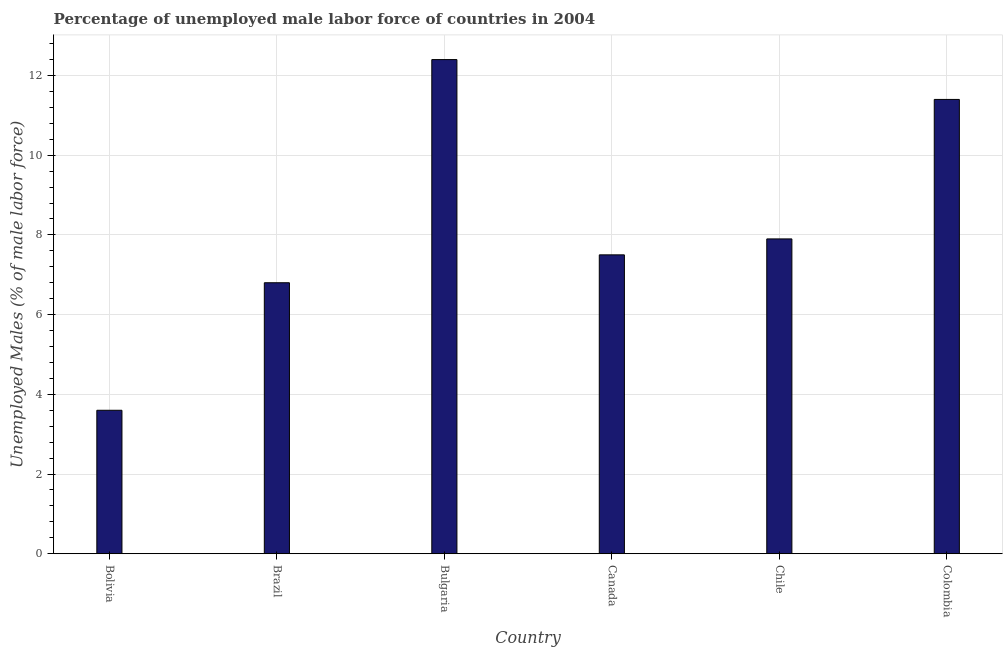Does the graph contain any zero values?
Make the answer very short. No. Does the graph contain grids?
Make the answer very short. Yes. What is the title of the graph?
Keep it short and to the point. Percentage of unemployed male labor force of countries in 2004. What is the label or title of the Y-axis?
Offer a terse response. Unemployed Males (% of male labor force). What is the total unemployed male labour force in Bulgaria?
Your answer should be compact. 12.4. Across all countries, what is the maximum total unemployed male labour force?
Provide a short and direct response. 12.4. Across all countries, what is the minimum total unemployed male labour force?
Offer a terse response. 3.6. What is the sum of the total unemployed male labour force?
Provide a short and direct response. 49.6. What is the average total unemployed male labour force per country?
Your answer should be very brief. 8.27. What is the median total unemployed male labour force?
Your answer should be very brief. 7.7. In how many countries, is the total unemployed male labour force greater than 11.6 %?
Offer a terse response. 1. What is the ratio of the total unemployed male labour force in Brazil to that in Chile?
Provide a succinct answer. 0.86. What is the difference between the highest and the second highest total unemployed male labour force?
Provide a succinct answer. 1. Is the sum of the total unemployed male labour force in Bolivia and Brazil greater than the maximum total unemployed male labour force across all countries?
Provide a succinct answer. No. Are all the bars in the graph horizontal?
Provide a succinct answer. No. How many countries are there in the graph?
Offer a terse response. 6. Are the values on the major ticks of Y-axis written in scientific E-notation?
Offer a very short reply. No. What is the Unemployed Males (% of male labor force) in Bolivia?
Provide a succinct answer. 3.6. What is the Unemployed Males (% of male labor force) of Brazil?
Your response must be concise. 6.8. What is the Unemployed Males (% of male labor force) in Bulgaria?
Your response must be concise. 12.4. What is the Unemployed Males (% of male labor force) of Canada?
Give a very brief answer. 7.5. What is the Unemployed Males (% of male labor force) of Chile?
Offer a terse response. 7.9. What is the Unemployed Males (% of male labor force) in Colombia?
Offer a terse response. 11.4. What is the difference between the Unemployed Males (% of male labor force) in Bolivia and Brazil?
Ensure brevity in your answer.  -3.2. What is the difference between the Unemployed Males (% of male labor force) in Bolivia and Bulgaria?
Your answer should be very brief. -8.8. What is the difference between the Unemployed Males (% of male labor force) in Bolivia and Chile?
Your answer should be very brief. -4.3. What is the difference between the Unemployed Males (% of male labor force) in Bolivia and Colombia?
Ensure brevity in your answer.  -7.8. What is the difference between the Unemployed Males (% of male labor force) in Brazil and Bulgaria?
Ensure brevity in your answer.  -5.6. What is the difference between the Unemployed Males (% of male labor force) in Brazil and Colombia?
Provide a short and direct response. -4.6. What is the difference between the Unemployed Males (% of male labor force) in Bulgaria and Colombia?
Make the answer very short. 1. What is the difference between the Unemployed Males (% of male labor force) in Canada and Chile?
Offer a terse response. -0.4. What is the ratio of the Unemployed Males (% of male labor force) in Bolivia to that in Brazil?
Make the answer very short. 0.53. What is the ratio of the Unemployed Males (% of male labor force) in Bolivia to that in Bulgaria?
Offer a terse response. 0.29. What is the ratio of the Unemployed Males (% of male labor force) in Bolivia to that in Canada?
Your answer should be compact. 0.48. What is the ratio of the Unemployed Males (% of male labor force) in Bolivia to that in Chile?
Keep it short and to the point. 0.46. What is the ratio of the Unemployed Males (% of male labor force) in Bolivia to that in Colombia?
Your answer should be compact. 0.32. What is the ratio of the Unemployed Males (% of male labor force) in Brazil to that in Bulgaria?
Offer a very short reply. 0.55. What is the ratio of the Unemployed Males (% of male labor force) in Brazil to that in Canada?
Your response must be concise. 0.91. What is the ratio of the Unemployed Males (% of male labor force) in Brazil to that in Chile?
Make the answer very short. 0.86. What is the ratio of the Unemployed Males (% of male labor force) in Brazil to that in Colombia?
Make the answer very short. 0.6. What is the ratio of the Unemployed Males (% of male labor force) in Bulgaria to that in Canada?
Your answer should be compact. 1.65. What is the ratio of the Unemployed Males (% of male labor force) in Bulgaria to that in Chile?
Provide a succinct answer. 1.57. What is the ratio of the Unemployed Males (% of male labor force) in Bulgaria to that in Colombia?
Offer a terse response. 1.09. What is the ratio of the Unemployed Males (% of male labor force) in Canada to that in Chile?
Your answer should be compact. 0.95. What is the ratio of the Unemployed Males (% of male labor force) in Canada to that in Colombia?
Make the answer very short. 0.66. What is the ratio of the Unemployed Males (% of male labor force) in Chile to that in Colombia?
Offer a terse response. 0.69. 